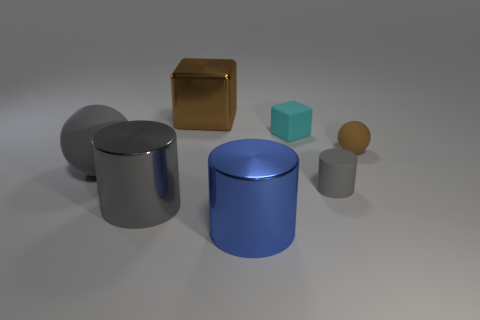Add 2 matte cylinders. How many objects exist? 9 Subtract all balls. How many objects are left? 5 Subtract all big blue metallic spheres. Subtract all big brown blocks. How many objects are left? 6 Add 2 brown things. How many brown things are left? 4 Add 3 blue things. How many blue things exist? 4 Subtract 0 gray blocks. How many objects are left? 7 